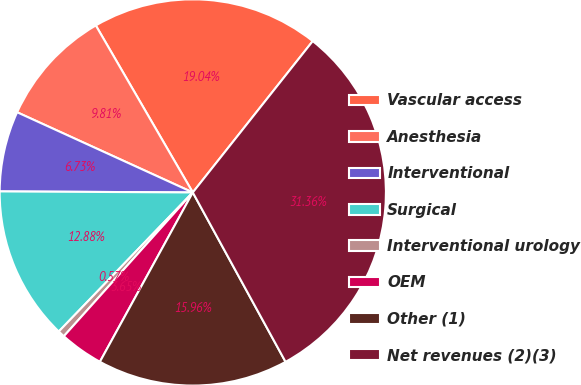Convert chart. <chart><loc_0><loc_0><loc_500><loc_500><pie_chart><fcel>Vascular access<fcel>Anesthesia<fcel>Interventional<fcel>Surgical<fcel>Interventional urology<fcel>OEM<fcel>Other (1)<fcel>Net revenues (2)(3)<nl><fcel>19.04%<fcel>9.81%<fcel>6.73%<fcel>12.88%<fcel>0.57%<fcel>3.65%<fcel>15.96%<fcel>31.36%<nl></chart> 